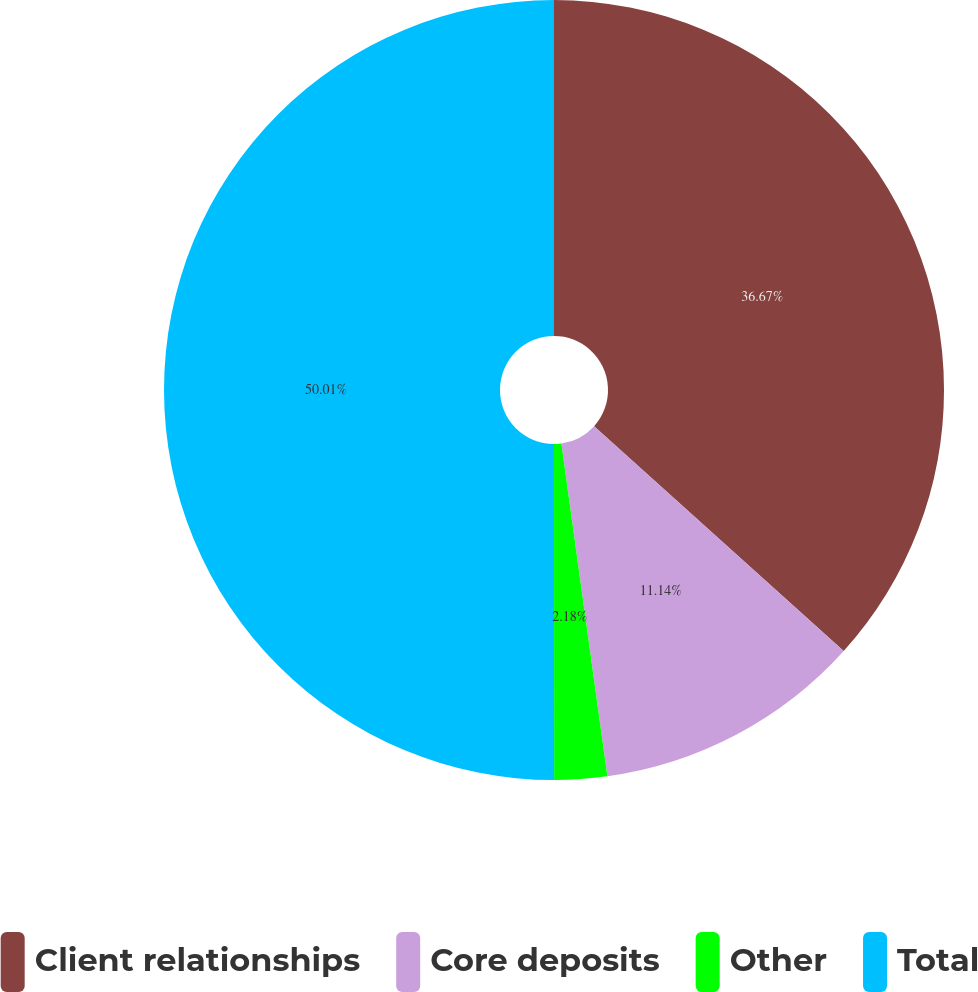Convert chart to OTSL. <chart><loc_0><loc_0><loc_500><loc_500><pie_chart><fcel>Client relationships<fcel>Core deposits<fcel>Other<fcel>Total<nl><fcel>36.67%<fcel>11.14%<fcel>2.18%<fcel>50.0%<nl></chart> 